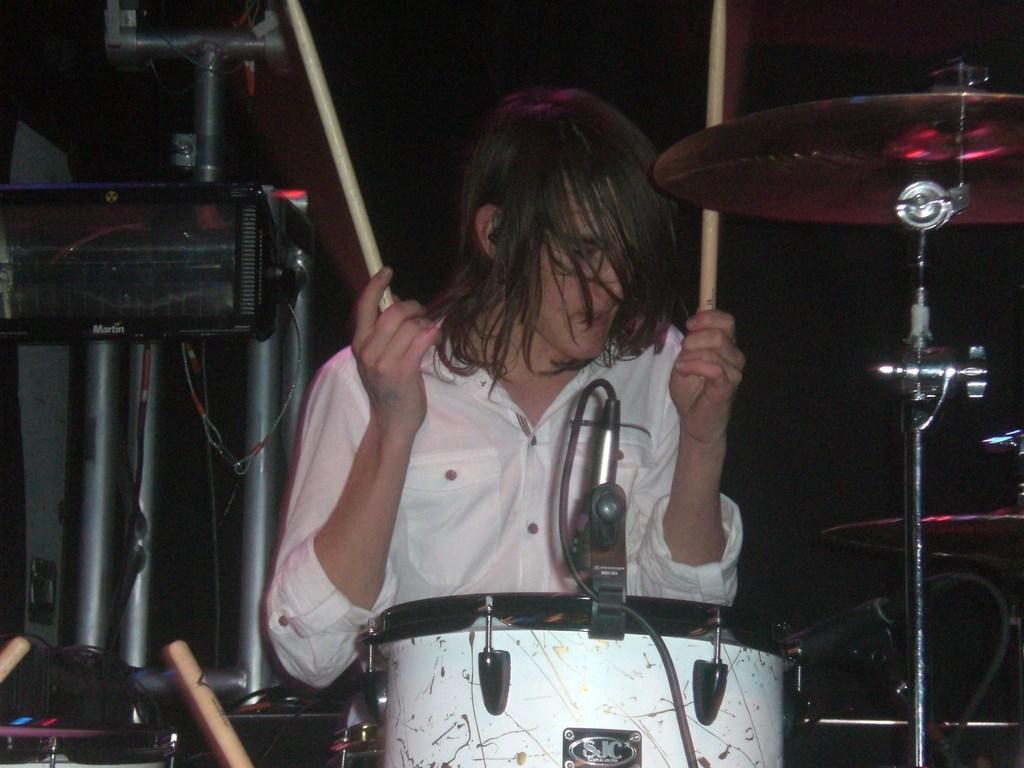In one or two sentences, can you explain what this image depicts? In this image, in the middle, we can see a man wearing a white color shirt is sitting and holding two sticks in his hand. The man is also sitting in front of a musical instrument. On the right side, we can see a musical instrument. On the left side, we can see some electronic instrument. In the background, we can see black color. 